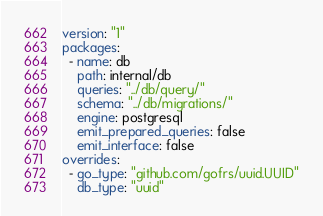Convert code to text. <code><loc_0><loc_0><loc_500><loc_500><_YAML_>version: "1"
packages:
  - name: db
    path: internal/db
    queries: "../db/query/"
    schema: "../db/migrations/"
    engine: postgresql
    emit_prepared_queries: false
    emit_interface: false
overrides:
  - go_type: "github.com/gofrs/uuid.UUID"
    db_type: "uuid"
</code> 